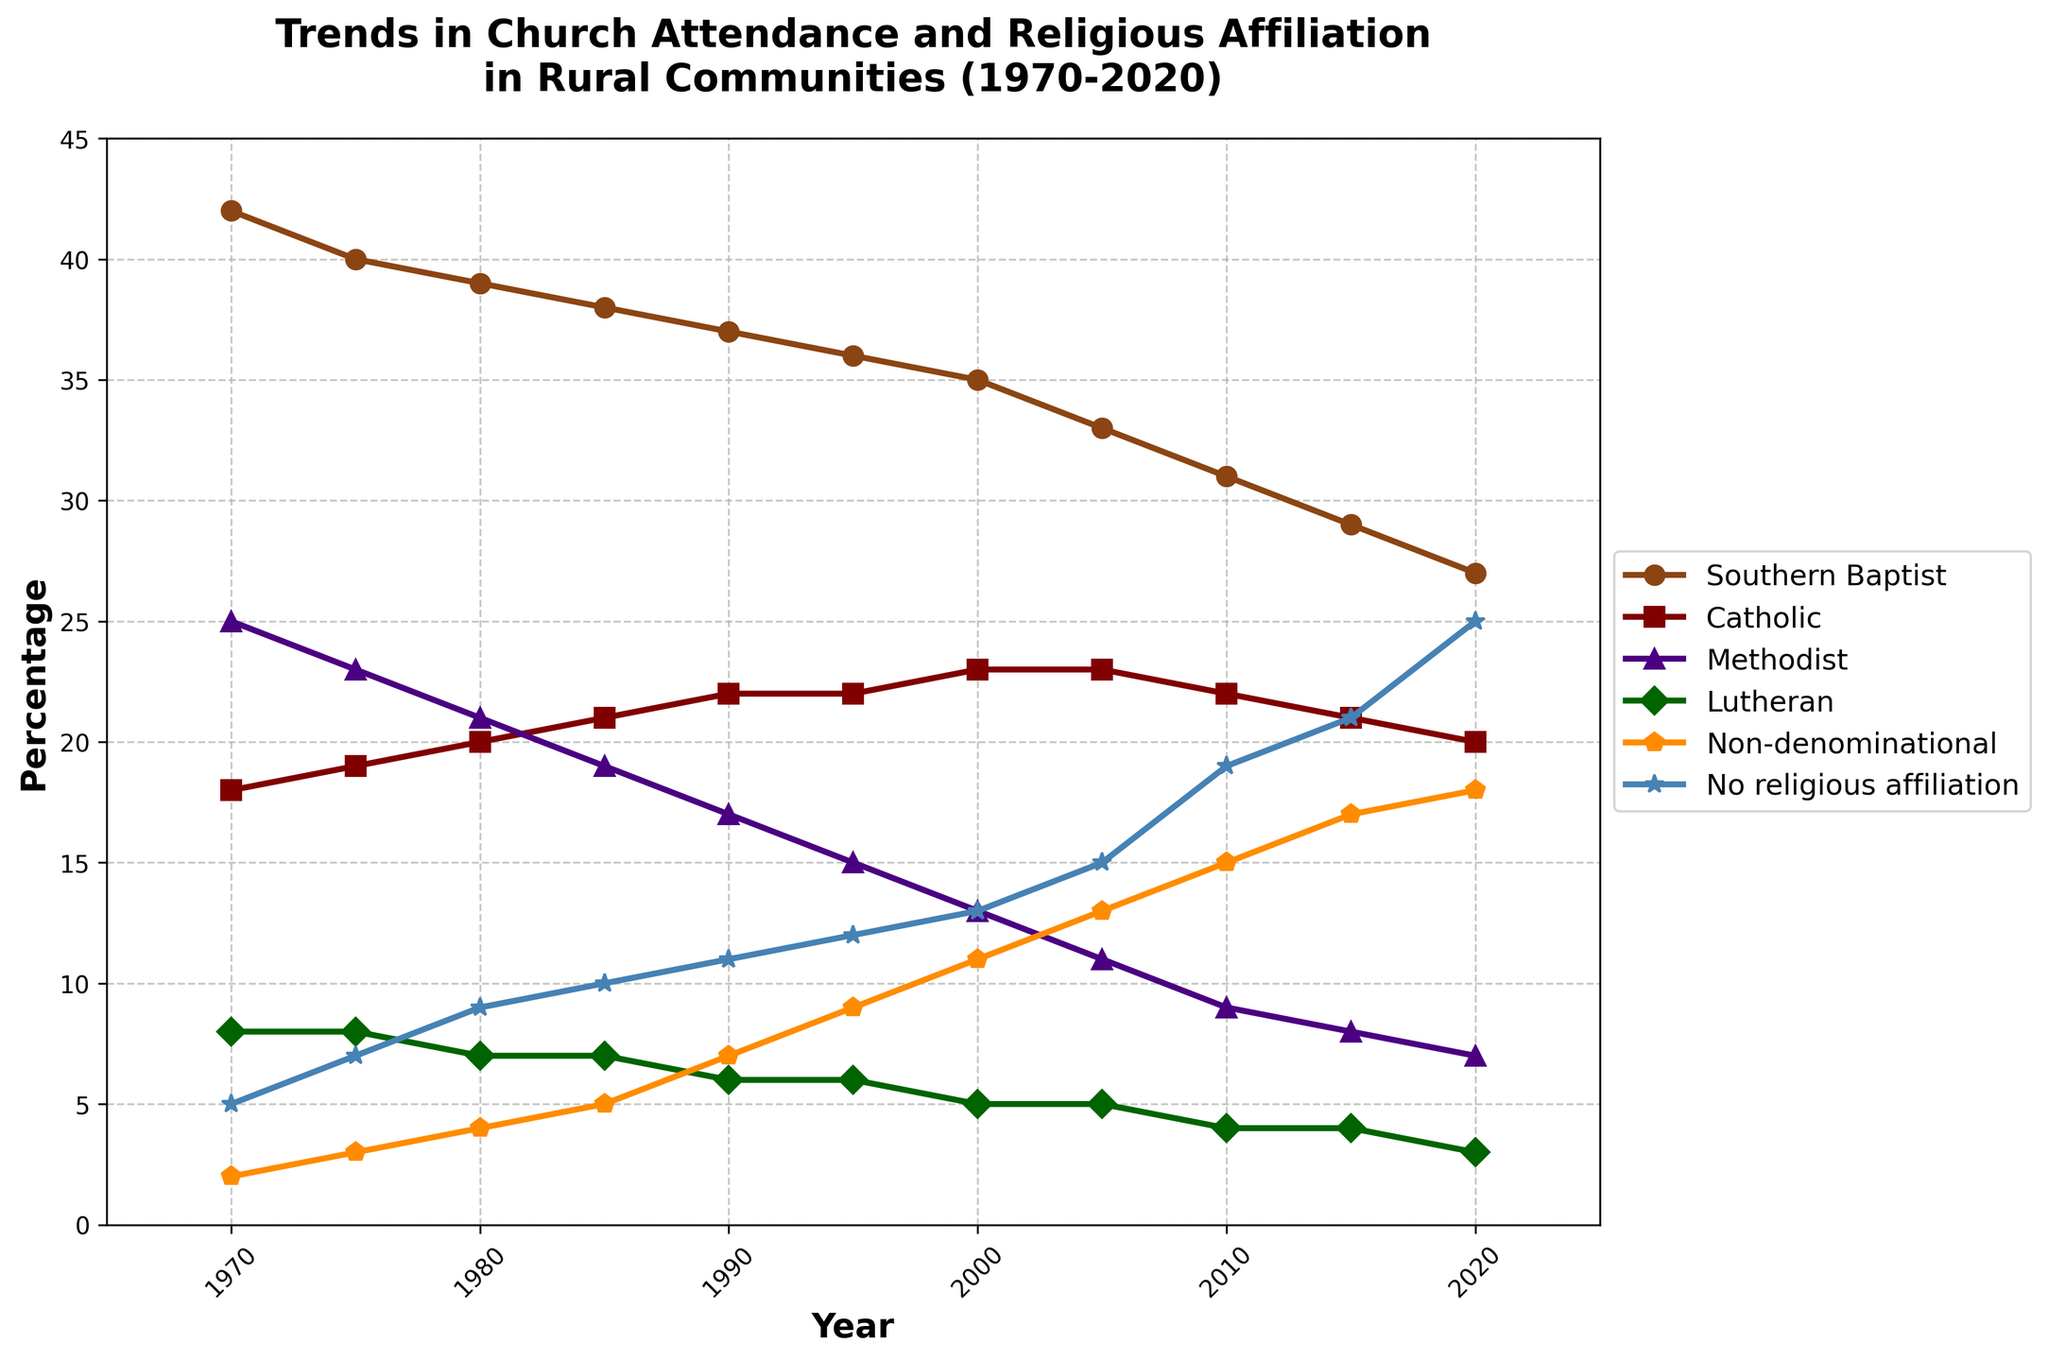Which religious group had the highest percentage of attendance in 1970? By looking at the values for each group in 1970, the Southern Baptist group had the highest percentage with 42%.
Answer: Southern Baptist How did the percentage of people with no religious affiliation change from 1970 to 2020? The percentage of people with no religious affiliation increased from 5% in 1970 to 25% in 2020. Subtracting the initial value from the final value, the change is 25% - 5% = 20%.
Answer: Increased by 20% Which group saw the largest decline in percentage from 1970 to 2020? By calculating the difference for each group between 1970 and 2020, Southern Baptist saw the largest decline, from 42% to 27%, which is a drop of 15%.
Answer: Southern Baptist In which decade did non-denominational attendance see the most significant increase? Analyzing the differences in values each decade for non-denominational attendance: 1970-1980: +2%, 1980-1990: +3%, 1990-2000: +4%, 2000-2010: +4%, 2010-2020: +1%. The most significant increase happened from 1990 to 2000 and from 2000 to 2010.
Answer: 1990-2000 and 2000-2010 What was the combined percentage of Catholic and No religious affiliation in 2010? By adding the values for Catholic (22%) and No religious affiliation (19%) in 2010, the combined percentage is 22% + 19% = 41%.
Answer: 41% Which religious group had a percentage that remained the same from 1970 to 1975? By looking at the values, the Lutheran group had a constant percentage of 8% from 1970 to 1975.
Answer: Lutheran By how much did the percentage of Methodist attendance decrease between 1985 and 2015? The percentage for Methodist in 1985 was 19%, and in 2015 it was 8%. Subtracting these values, the decrease is 19% - 8% = 11%.
Answer: 11% Which religious group overtook another in 1995, and which groups were involved? By comparing the percentages in 1995, Non-denominational (9%) overtook Lutheran (6%) in attendance.
Answer: Non-denominational overtook Lutheran Between which two years did Southern Baptists experience the steepest decline in attendance, and what was the percentage drop? By examining the year-to-year differences, the steepest decline for Southern Baptists was between 2015 and 2020, from 29% to 27%, a drop of 2%.
Answer: 2015-2020, 2% 